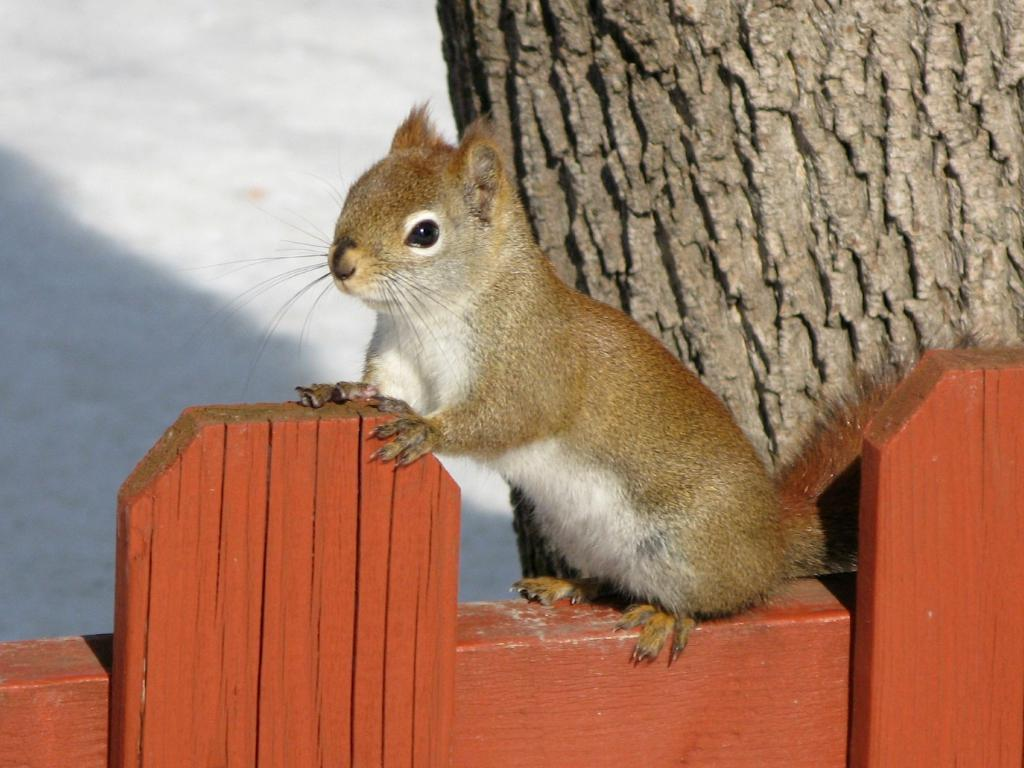What animal can be seen in the picture? There is a squirrel in the picture. Where is the squirrel located in the picture? The squirrel is sitting on a fence. What is the color of the squirrel? The squirrel is brown in color. Does the squirrel have any distinguishing features? Yes, the squirrel has a tail. What can be seen in the background of the picture? There is a tree trunk visible in the background of the picture. Is the squirrel using a plough in the picture? No, there is no plough present in the image. What type of dog can be seen playing with the squirrel in the picture? There is no dog present in the image; it only features a squirrel. 